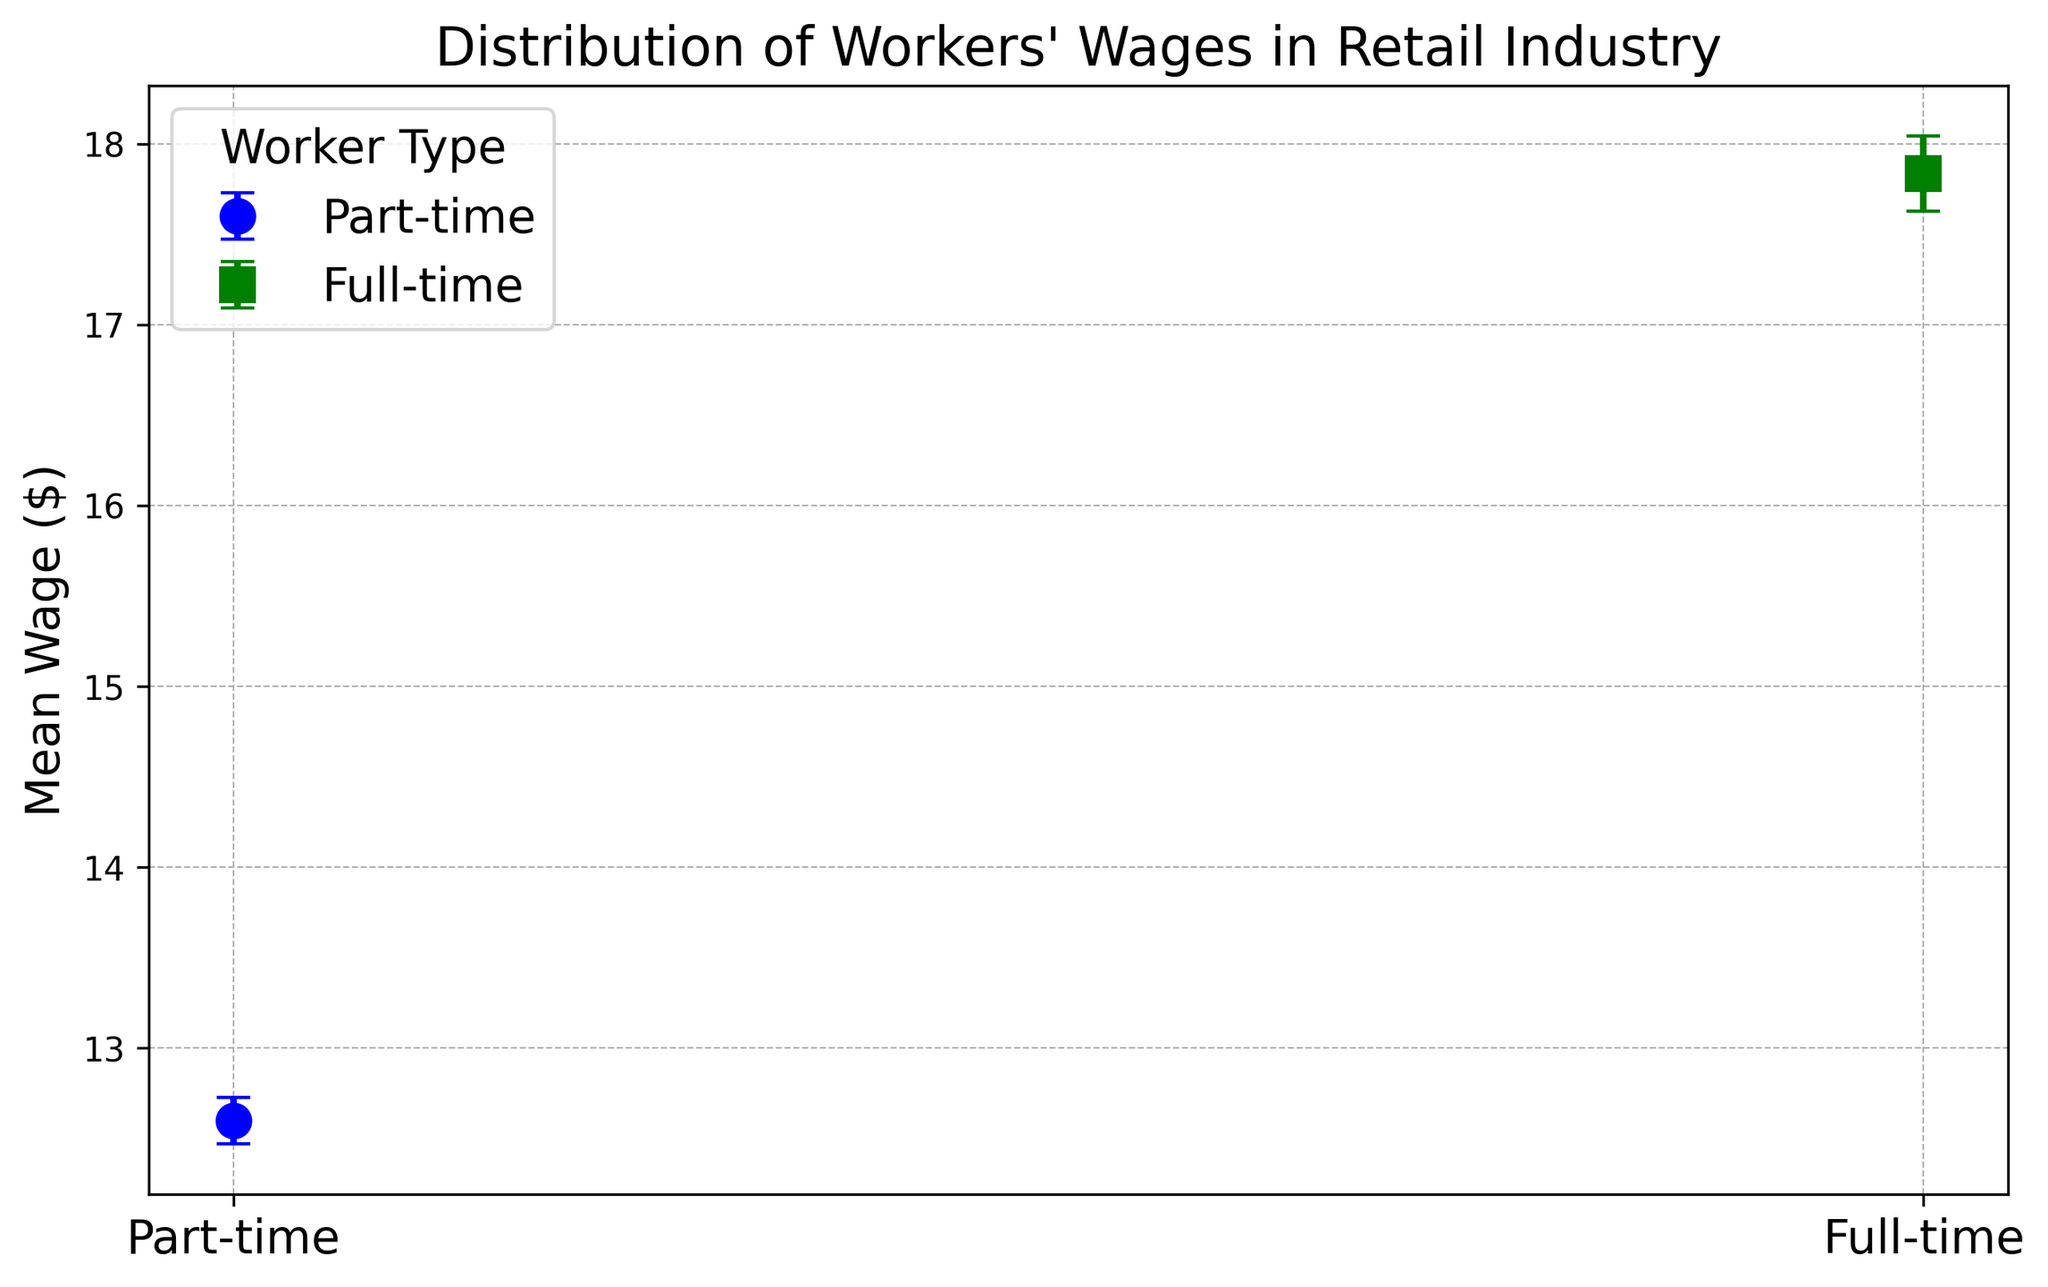Which worker type has a higher mean wage? Look at the y-coordinates of the markers representing the mean wages for both part-time and full-time workers. The full-time workers' marker is higher on the y-axis, indicating a higher mean wage.
Answer: Full-time Which worker type has a greater standard error? Standard error is represented by the length of the error bars. By comparing the lengths of the error bars, the full-time workers have longer error bars, indicating a greater standard error.
Answer: Full-time What is the approximate mean wage difference between part-time and full-time workers? To find the wage difference, subtract the mean wage of part-time workers from the mean wage of full-time workers. If the mean wage of part-time workers is around $12.60 and full-time is around $17.84, the difference is $17.84 - $12.60.
Answer: $5.24 What colors represent the part-time and full-time workers? The figure uses colors to differentiate worker types. The part-time workers are represented in blue, and full-time workers are represented in green.
Answer: Blue for part-time, Green for full-time Comparing the error bars of both worker types, which is visually longer? Observe the error bars length for both worker types. The error bars for the full-time workers are longer than those of part-time workers.
Answer: Full-time Is there a significant overlap in the standard error bars between part-time and full-time workers? Check the overlap of the standard error bars. There is no significant overlap between the part-time and full-time wages' standard error bars, indicating less similarity in wage distribution ranges.
Answer: No What's the approximate range of the mean wages for part-time workers? Calculate the range by adding and subtracting the standard error from the mean wage. The mean wage is approximately $12.60, and the average standard error is roughly $0.13. So the range is about $12.60 ± $0.13.
Answer: $12.47 to $12.73 What's the difference in the mean wage relative to their standard errors for part-time and full-time workers? To find the difference weighted by their respective standard errors, calculate (mean difference) ÷ (standard error of part-time workers + standard error of full-time workers). Mean difference is roughly $5.24 and combined error is $0.13 (part-time) + $0.21 (full-time). So, $5.24 ÷ $0.34.
Answer: 15.41 Which worker type has less variability in their wages? Variability can be visually assessed by the error bar length. Part-time workers have shorter error bars, indicating less variability in their wages compared to full-time workers.
Answer: Part-time Based on the plot, how would you describe the overall wage distribution for the two worker types? By analyzing the plot, full-time workers have a higher mean wage and more variability in wages (longer error bars), while part-time workers have a lower mean wage with less variability (shorter error bars).
Answer: Higher and more variable for full-time, Lower and less variable for part-time 